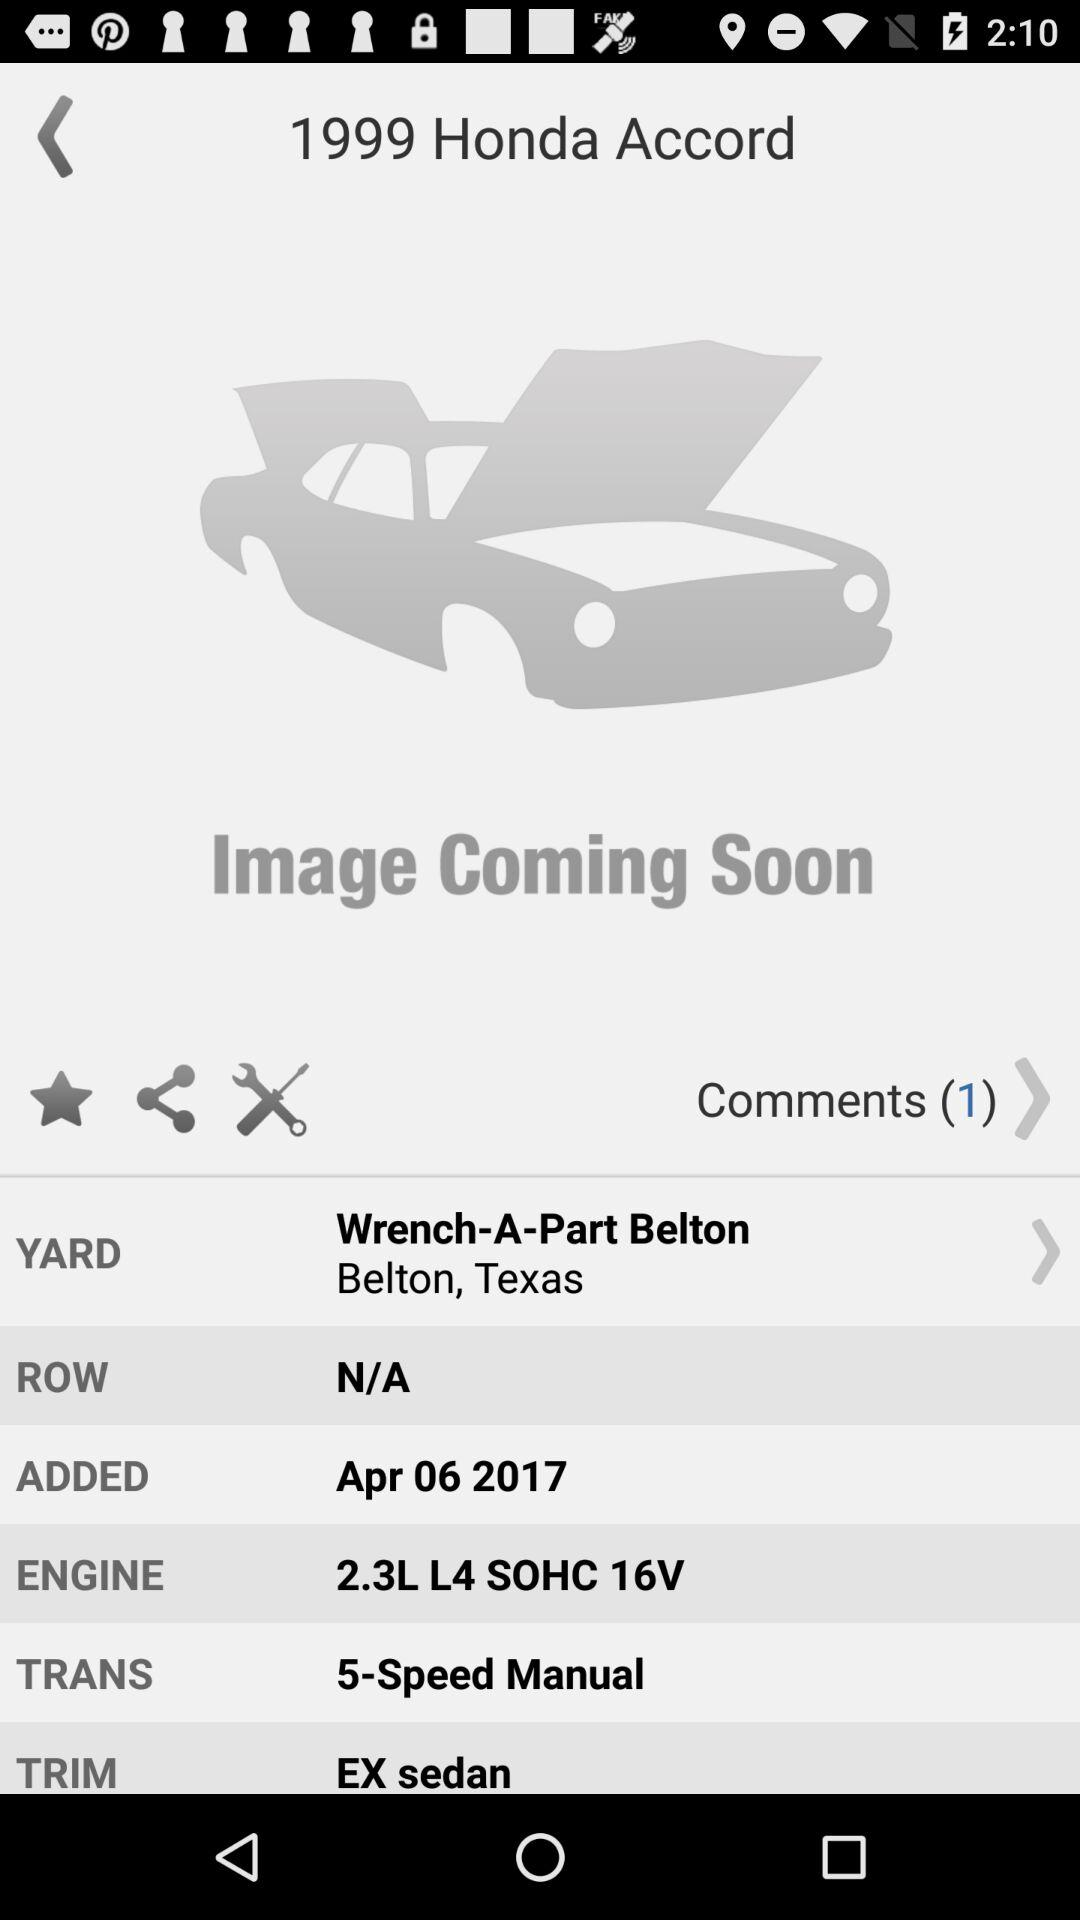Is this car commonly found in salvage yards? Yes, the 1999 Honda Accord is quite a common vehicle to find in salvage yards due to its popularity and the high number of units sold during its production years. It's a frequently sought-after model for affordable parts replacement. 